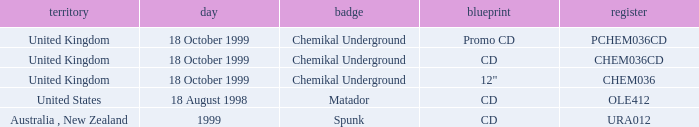What label is associated with the United Kingdom and the chem036 catalog? Chemikal Underground. 